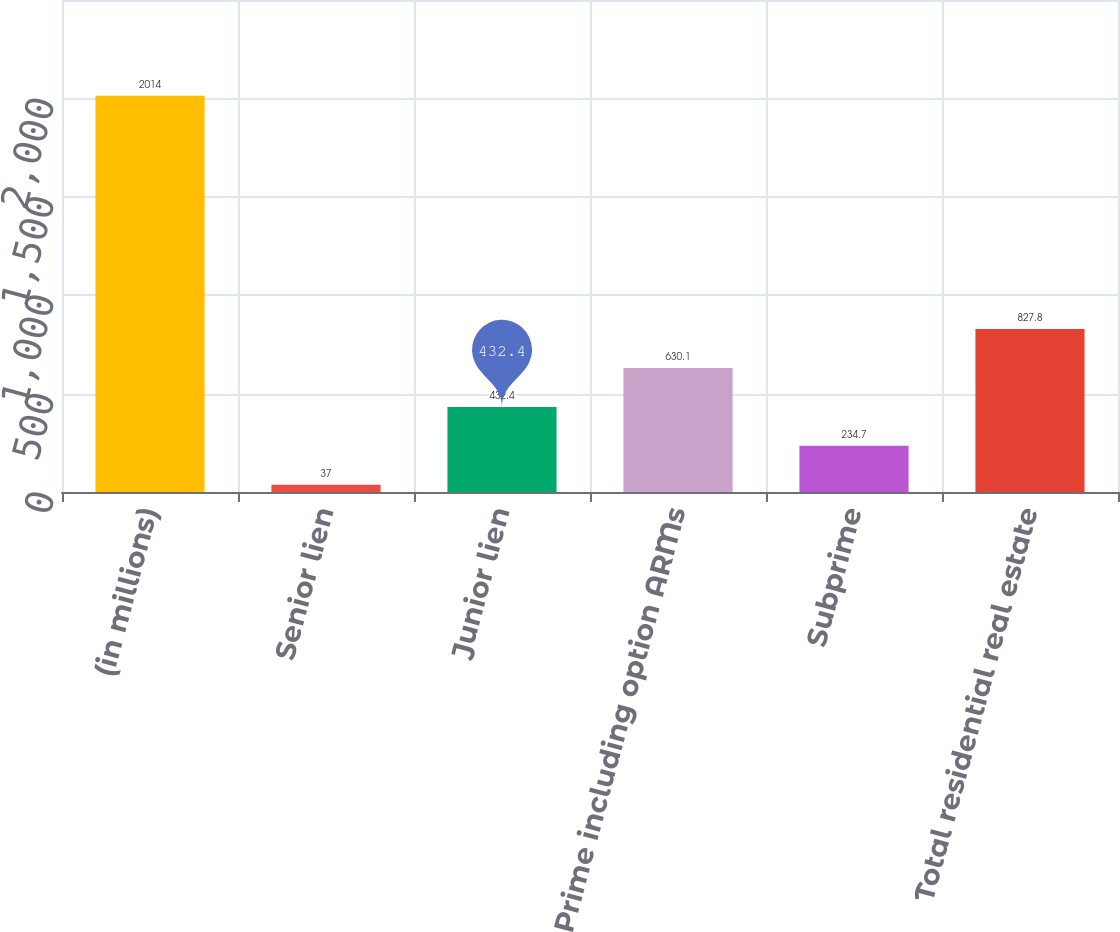Convert chart to OTSL. <chart><loc_0><loc_0><loc_500><loc_500><bar_chart><fcel>(in millions)<fcel>Senior lien<fcel>Junior lien<fcel>Prime including option ARMs<fcel>Subprime<fcel>Total residential real estate<nl><fcel>2014<fcel>37<fcel>432.4<fcel>630.1<fcel>234.7<fcel>827.8<nl></chart> 